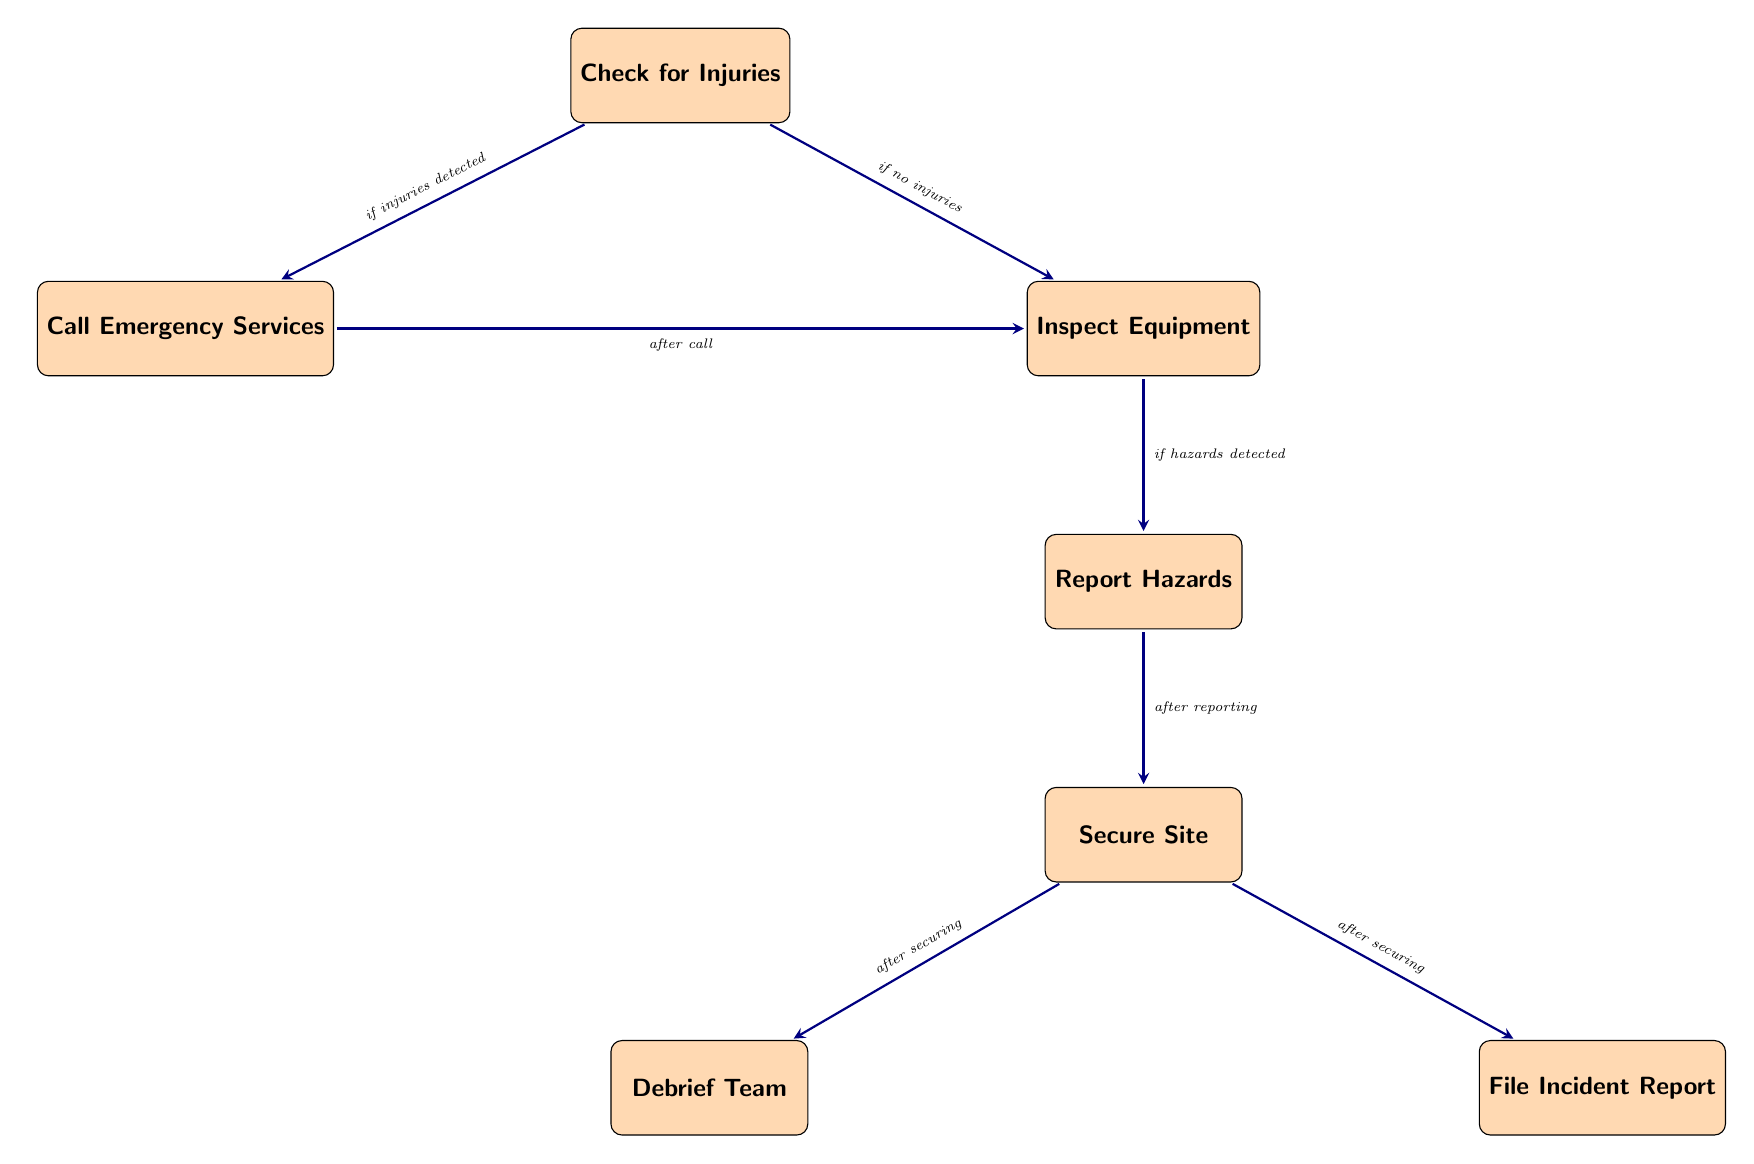What's the first node in the flow chart? The flow chart starts with the node labeled "Check for Injuries." This node serves as the initial step in the post-evacuation safety check process.
Answer: Check for Injuries How many nodes are present in the diagram? Counting all the nodes in the flow chart, there are seven distinct nodes that outline the post-evacuation procedures for crane operators.
Answer: Seven What condition leads to calling emergency services? The flow chart specifies that emergency services are called only if injuries are detected during the initial check. This is the condition for transitioning to that node.
Answer: If injuries detected What action follows securing the site? After the site is secured, the next actions in the flow chart involve either debriefing the team or filing an incident report, which occurs after securing the area.
Answer: Debrief Team and File Incident Report What is the final step in the process depicted in the flow chart? The last action described in the flow chart is "File Incident Report," which is the concluding task after the team has been debriefed following the evacuation process.
Answer: File Incident Report What node connects to "Inspect Equipment" if no injuries are found? The connection to "Inspect Equipment" occurs directly from the "Check for Injuries" node under the condition that there are no injuries detected.
Answer: Inspect Equipment What must be done after reporting hazards? After completing the hazard reporting step, the next action that must be taken according to the flow chart is to secure the site, ensuring that it remains safe and free from dangers.
Answer: Secure Site 